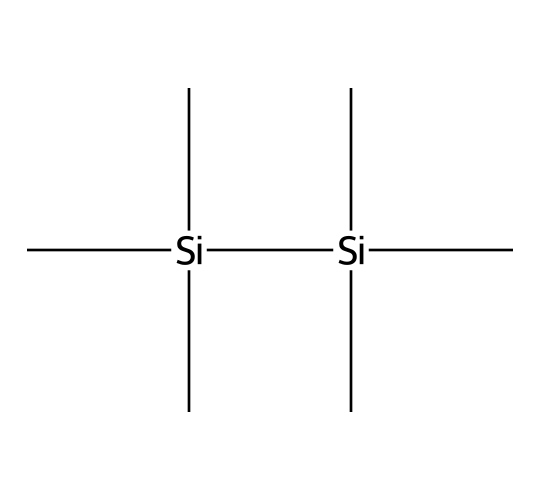What is the name of the compound represented by the SMILES? The SMILES notation indicates the compound is hexamethyldisilane, which derives its name from having six methyl groups bonded to two silicon atoms.
Answer: hexamethyldisilane How many silicon atoms are in the structure? Analyzing the SMILES shows there are two silicon atoms, as denoted by 'Si' appearing twice.
Answer: 2 What is the total number of carbon atoms in this structure? The SMILES indicates there are six methyl groups (C) attached to each silicon atom, yielding a total of six carbon atoms (since each Si has three C) plus an additional six from another dependence of the terminal methyl, leading to a total of 12.
Answer: 12 What type of chemical compound is hexamethyldisilane? Hexamethyldisilane belongs to the group of silanes, characterized by silicon atoms bonded to carbon and hydrogen atoms.
Answer: silane How many bonds connect the silicon atoms in the structure? There is a single bond connecting the two silicon atoms within the structure, making it a disilane compound.
Answer: 1 What is the hybridization state of the silicon atoms in hexamethyldisilane? The silicon atoms are typically sp3 hybridized due to their four substituent groups, which include the methyl groups.
Answer: sp3 What property does the presence of multiple methyl groups impart to hexamethyldisilane? The multiple methyl groups increase the hydrophobic character of the compound, making it less polar and contributing to its stability in silicon-based materials.
Answer: hydrophobic 